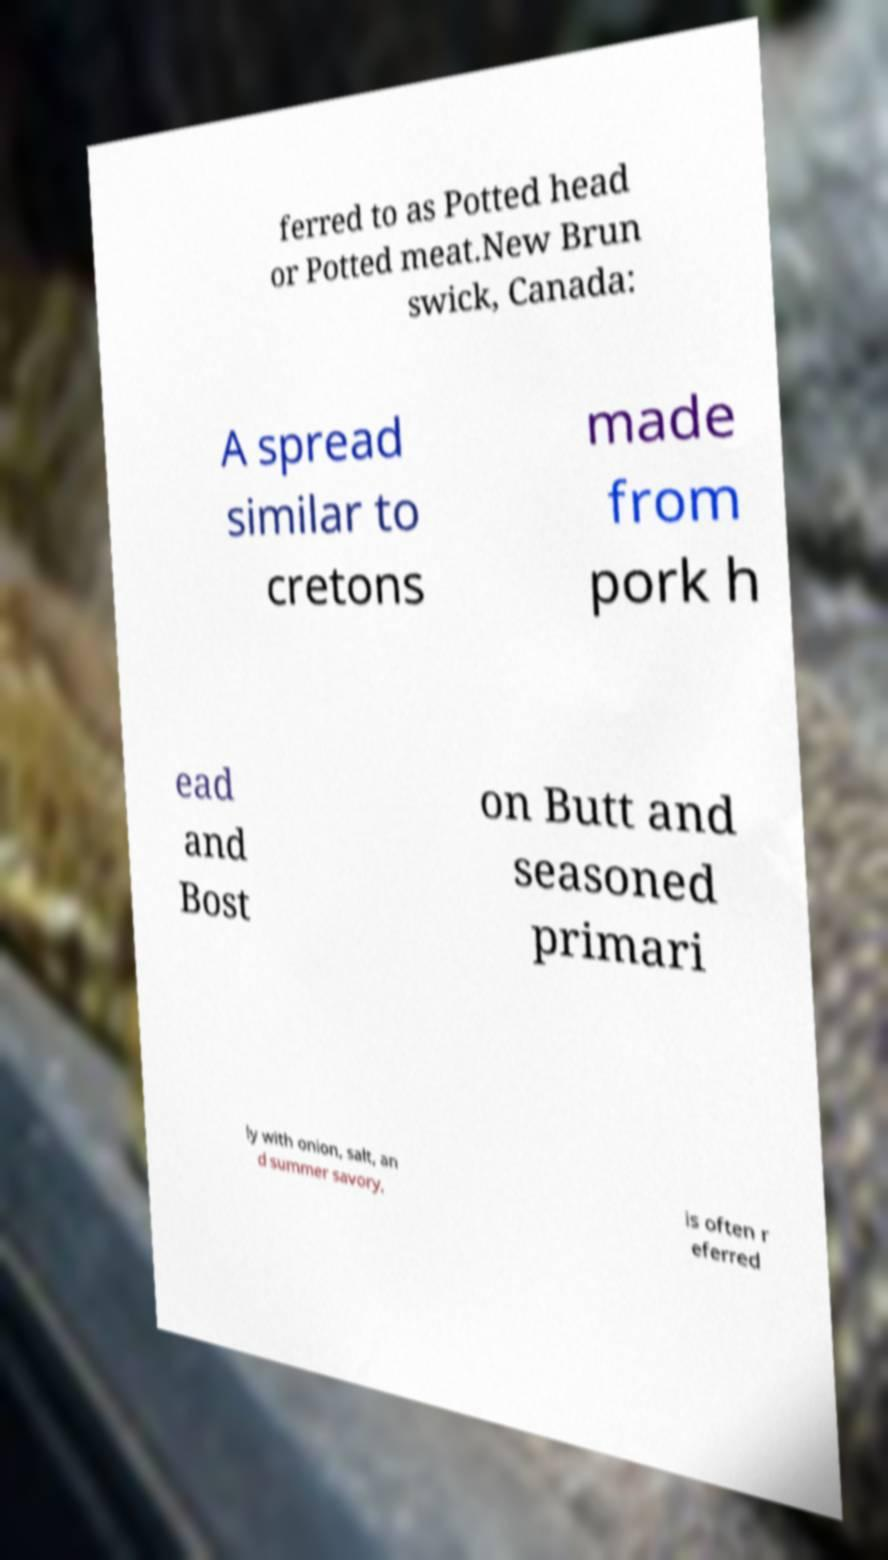For documentation purposes, I need the text within this image transcribed. Could you provide that? ferred to as Potted head or Potted meat.New Brun swick, Canada: A spread similar to cretons made from pork h ead and Bost on Butt and seasoned primari ly with onion, salt, an d summer savory, is often r eferred 